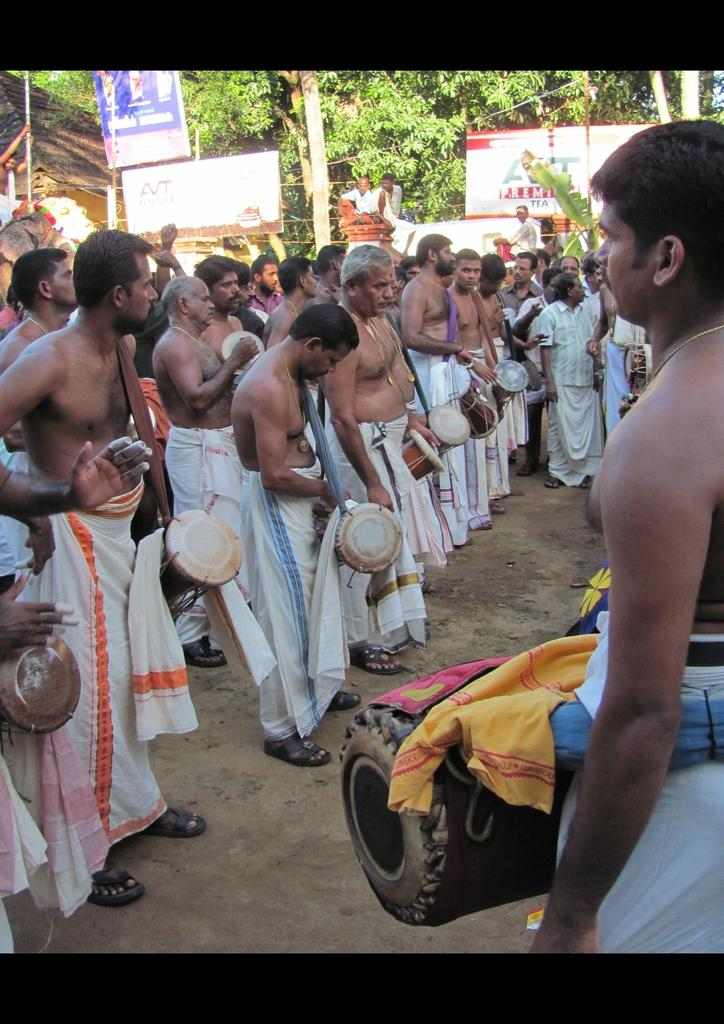What is happening in the image involving a group of people? The people in the image are playing drums. How are the people positioned in the image? The people are standing. What can be seen in the background of the image? There are trees and banners visible in the background. What type of book is being used as a drum in the image? There is no book being used as a drum in the image; the people are playing traditional drums. 